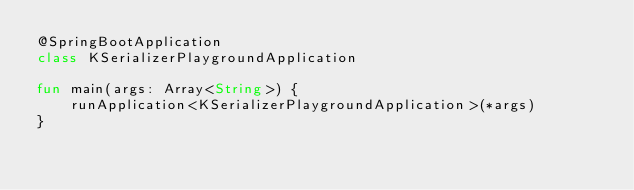Convert code to text. <code><loc_0><loc_0><loc_500><loc_500><_Kotlin_>@SpringBootApplication
class KSerializerPlaygroundApplication

fun main(args: Array<String>) {
	runApplication<KSerializerPlaygroundApplication>(*args)
}
</code> 